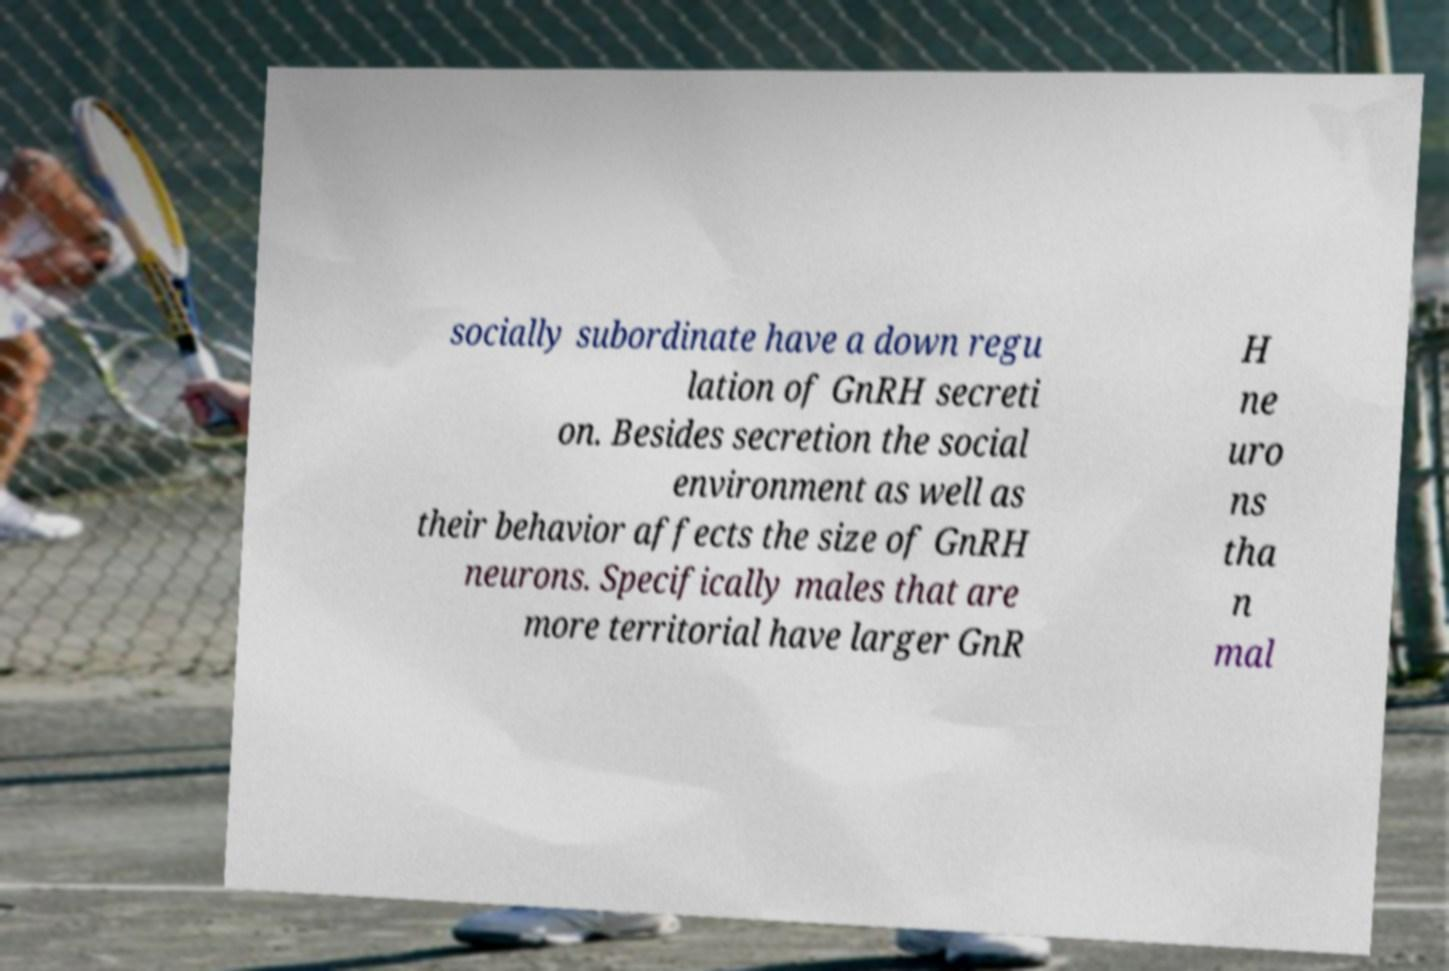Please read and relay the text visible in this image. What does it say? socially subordinate have a down regu lation of GnRH secreti on. Besides secretion the social environment as well as their behavior affects the size of GnRH neurons. Specifically males that are more territorial have larger GnR H ne uro ns tha n mal 